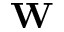<formula> <loc_0><loc_0><loc_500><loc_500>W</formula> 